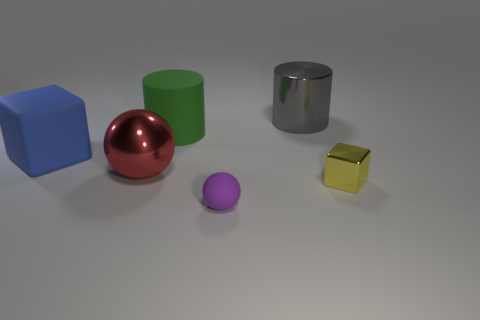Are there any yellow shiny things that have the same size as the rubber ball?
Your response must be concise. Yes. What color is the cube that is the same material as the red thing?
Give a very brief answer. Yellow. How many red objects are on the right side of the big cylinder in front of the big gray metallic cylinder?
Your response must be concise. 0. There is a thing that is both on the right side of the purple sphere and on the left side of the yellow object; what is it made of?
Keep it short and to the point. Metal. There is a big red object that is to the left of the rubber sphere; does it have the same shape as the small metal thing?
Your answer should be very brief. No. Is the number of big green cylinders less than the number of tiny red rubber things?
Provide a succinct answer. No. What number of cylinders have the same color as the large metallic ball?
Your response must be concise. 0. There is a big cube; does it have the same color as the small thing that is on the left side of the small yellow metal object?
Make the answer very short. No. Is the number of large gray matte blocks greater than the number of balls?
Your response must be concise. No. There is another rubber object that is the same shape as the red object; what is its size?
Your response must be concise. Small. 